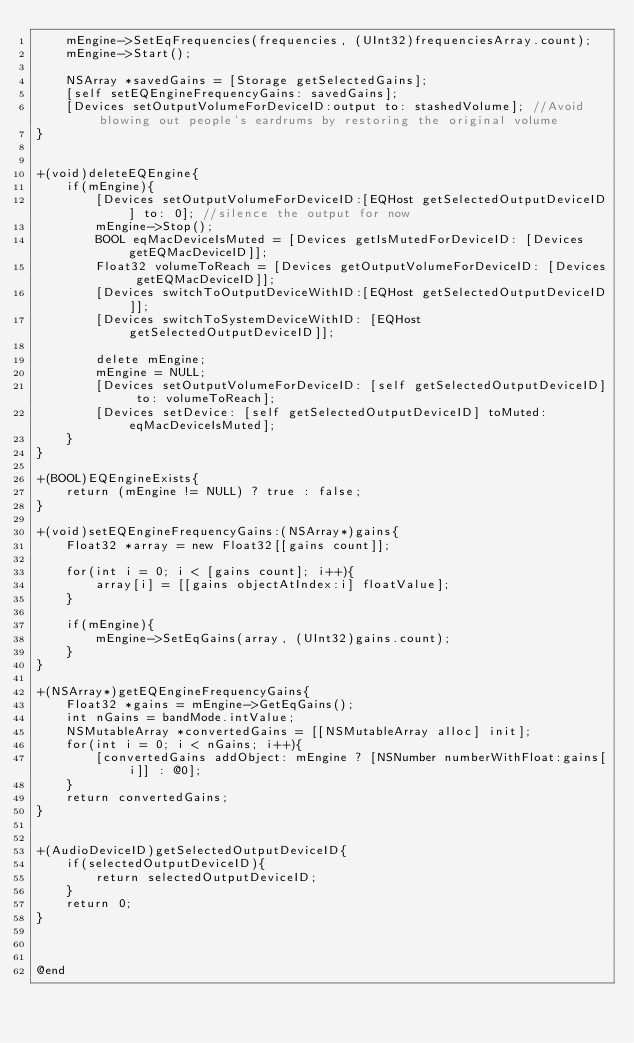<code> <loc_0><loc_0><loc_500><loc_500><_ObjectiveC_>    mEngine->SetEqFrequencies(frequencies, (UInt32)frequenciesArray.count);
    mEngine->Start();
    
    NSArray *savedGains = [Storage getSelectedGains];
    [self setEQEngineFrequencyGains: savedGains];
    [Devices setOutputVolumeForDeviceID:output to: stashedVolume]; //Avoid blowing out people's eardrums by restoring the original volume
}


+(void)deleteEQEngine{
    if(mEngine){
        [Devices setOutputVolumeForDeviceID:[EQHost getSelectedOutputDeviceID] to: 0]; //silence the output for now
        mEngine->Stop();
        BOOL eqMacDeviceIsMuted = [Devices getIsMutedForDeviceID: [Devices getEQMacDeviceID]];
        Float32 volumeToReach = [Devices getOutputVolumeForDeviceID: [Devices getEQMacDeviceID]];
        [Devices switchToOutputDeviceWithID:[EQHost getSelectedOutputDeviceID]];
        [Devices switchToSystemDeviceWithID: [EQHost getSelectedOutputDeviceID]];

        delete mEngine;
        mEngine = NULL;
        [Devices setOutputVolumeForDeviceID: [self getSelectedOutputDeviceID] to: volumeToReach];
        [Devices setDevice: [self getSelectedOutputDeviceID] toMuted: eqMacDeviceIsMuted];
    }
}

+(BOOL)EQEngineExists{
    return (mEngine != NULL) ? true : false;
}

+(void)setEQEngineFrequencyGains:(NSArray*)gains{
    Float32 *array = new Float32[[gains count]];
    
    for(int i = 0; i < [gains count]; i++){
        array[i] = [[gains objectAtIndex:i] floatValue];
    }
    
    if(mEngine){
        mEngine->SetEqGains(array, (UInt32)gains.count);
    }
}

+(NSArray*)getEQEngineFrequencyGains{
    Float32 *gains = mEngine->GetEqGains();
    int nGains = bandMode.intValue;
    NSMutableArray *convertedGains = [[NSMutableArray alloc] init];
    for(int i = 0; i < nGains; i++){
        [convertedGains addObject: mEngine ? [NSNumber numberWithFloat:gains[i]] : @0];
    }
    return convertedGains;
}


+(AudioDeviceID)getSelectedOutputDeviceID{
    if(selectedOutputDeviceID){
        return selectedOutputDeviceID;
    }
    return 0;
}



@end
</code> 